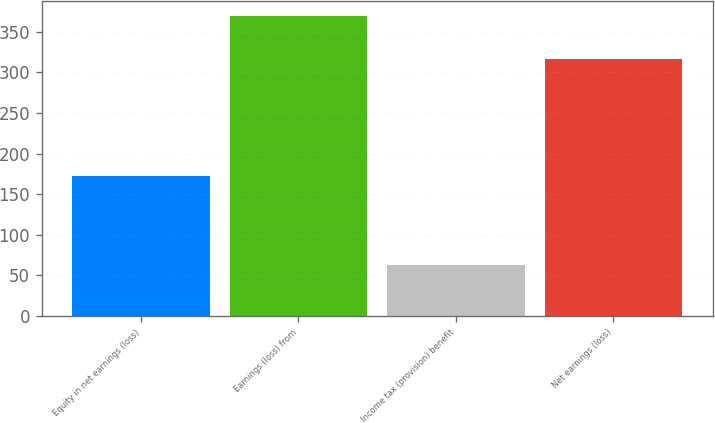<chart> <loc_0><loc_0><loc_500><loc_500><bar_chart><fcel>Equity in net earnings (loss)<fcel>Earnings (loss) from<fcel>Income tax (provision) benefit<fcel>Net earnings (loss)<nl><fcel>172<fcel>370<fcel>63<fcel>317<nl></chart> 